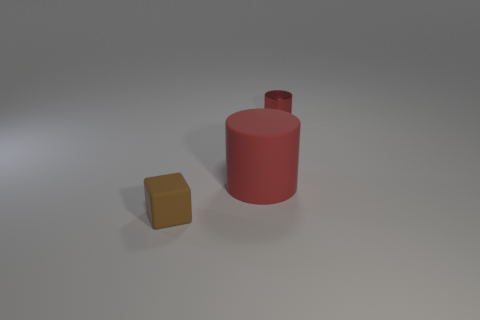Are there any other things that are the same material as the small red cylinder?
Give a very brief answer. No. Is the material of the tiny thing behind the brown cube the same as the cube in front of the rubber cylinder?
Your answer should be compact. No. What number of things are either cylinders that are left of the small red object or small cyan spheres?
Provide a short and direct response. 1. Is the number of matte things in front of the brown block less than the number of brown matte cubes on the right side of the tiny metal thing?
Your answer should be very brief. No. How many other things are there of the same size as the red matte cylinder?
Provide a succinct answer. 0. Does the brown object have the same material as the small thing that is behind the brown block?
Your response must be concise. No. What number of objects are cylinders behind the large thing or small objects behind the tiny brown matte block?
Make the answer very short. 1. What color is the tiny rubber block?
Provide a short and direct response. Brown. Is the number of small cubes that are left of the brown rubber object less than the number of small purple rubber things?
Make the answer very short. No. Are there any other things that have the same shape as the small brown object?
Your answer should be very brief. No. 